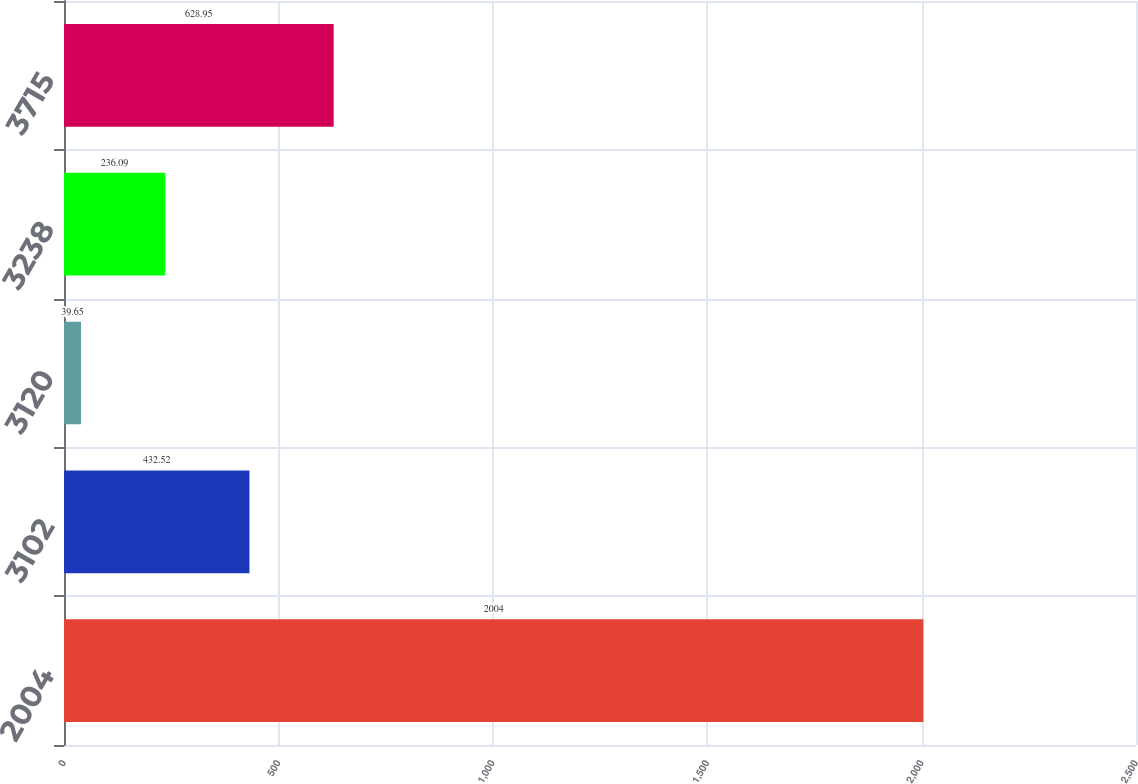Convert chart to OTSL. <chart><loc_0><loc_0><loc_500><loc_500><bar_chart><fcel>2004<fcel>3102<fcel>3120<fcel>3238<fcel>3715<nl><fcel>2004<fcel>432.52<fcel>39.65<fcel>236.09<fcel>628.95<nl></chart> 